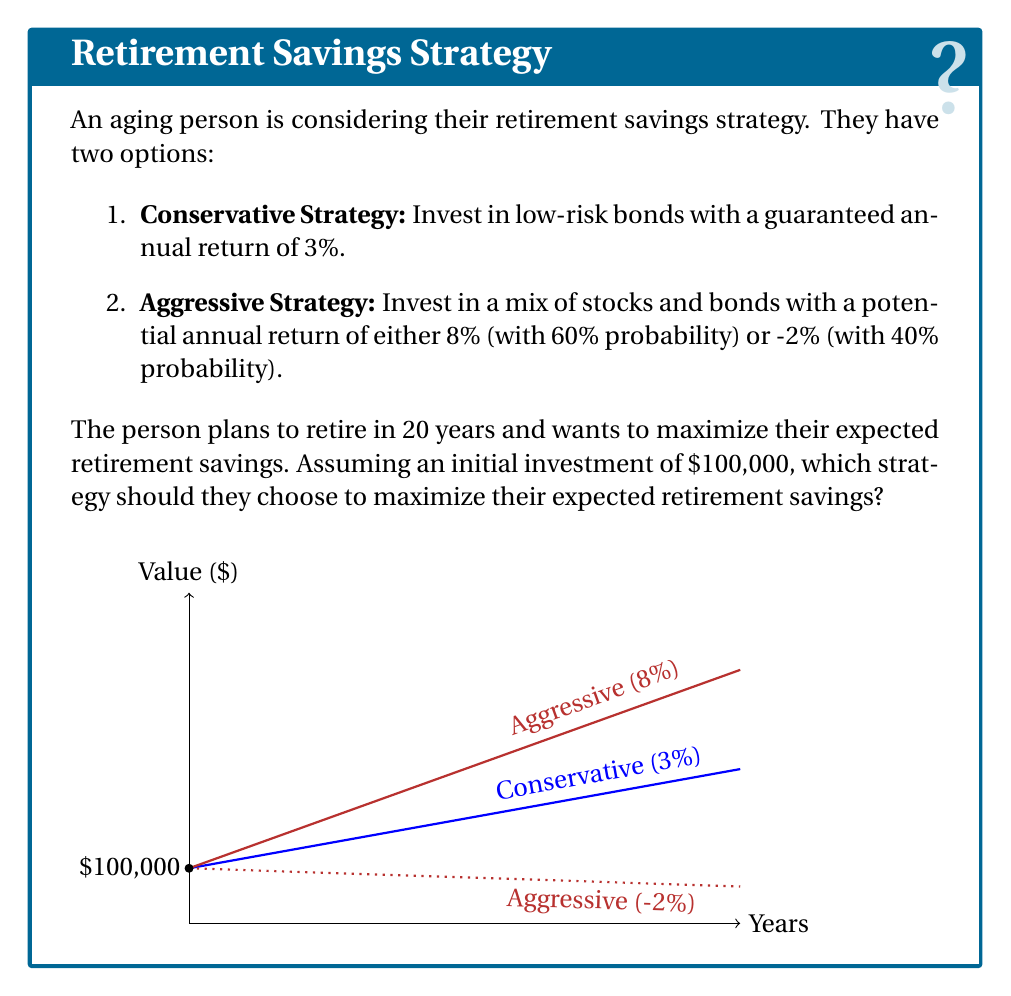Provide a solution to this math problem. Let's approach this problem step-by-step using game theory concepts:

1) First, we need to calculate the expected value of each strategy after 20 years.

2) For the Conservative Strategy:
   The value after 20 years will be:
   $$100,000 * (1.03)^{20} = 180,611.12$$

3) For the Aggressive Strategy:
   We need to calculate the expected annual return:
   $$E(\text{return}) = 0.60 * 8\% + 0.40 * (-2\%) = 4\%$$

   The expected value after 20 years will be:
   $$100,000 * (1.04)^{20} = 219,111.93$$

4) In game theory, we often use the concept of expected utility to make decisions under uncertainty. In this case, we're assuming the person is risk-neutral (only cares about expected value).

5) Comparing the two strategies:
   Conservative: $180,611.12
   Aggressive: $219,111.93

6) The Aggressive Strategy has a higher expected value, but it also comes with more risk. The worst-case scenario for the Aggressive Strategy (if we get -2% return every year) would be:
   $$100,000 * (0.98)^{20} = 66,761.26$$

7) However, given that the question asks to maximize expected retirement savings, and assuming risk-neutrality, the optimal strategy is the one with the highest expected value.
Answer: Aggressive Strategy 